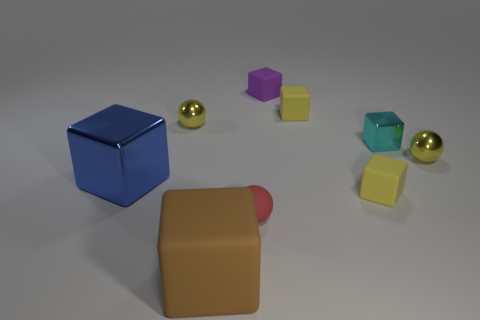What is the shape of the cyan metal thing that is the same size as the purple cube?
Keep it short and to the point. Cube. What shape is the small purple matte thing that is behind the tiny yellow block that is behind the sphere that is to the left of the small red matte ball?
Give a very brief answer. Cube. Do the shiny sphere that is to the right of the brown rubber cube and the big object that is in front of the big blue block have the same color?
Offer a very short reply. No. What number of brown rubber blocks are there?
Make the answer very short. 1. There is a large blue block; are there any small metallic spheres left of it?
Offer a terse response. No. Are the big block that is behind the brown block and the yellow cube in front of the small cyan metal cube made of the same material?
Provide a succinct answer. No. Is the number of tiny cyan shiny blocks that are left of the rubber ball less than the number of small gray metal objects?
Your answer should be very brief. No. What is the color of the big cube right of the big blue metallic block?
Your answer should be very brief. Brown. What material is the yellow cube that is to the left of the small rubber block that is in front of the big blue cube?
Offer a terse response. Rubber. Is there a yellow rubber cube of the same size as the blue cube?
Offer a very short reply. No. 